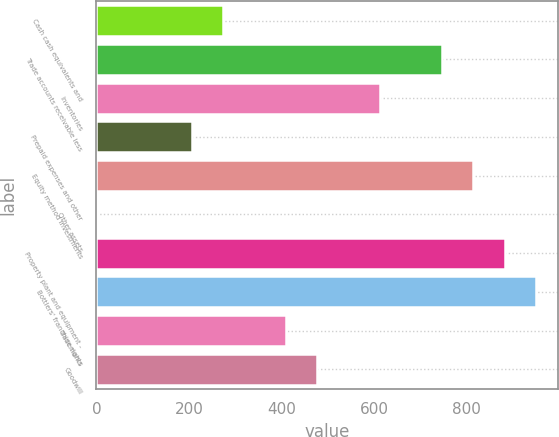<chart> <loc_0><loc_0><loc_500><loc_500><bar_chart><fcel>Cash cash equivalents and<fcel>Trade accounts receivable less<fcel>Inventories<fcel>Prepaid expenses and other<fcel>Equity method investments<fcel>Other assets<fcel>Property plant and equipment -<fcel>Bottlers' franchise rights<fcel>Trademarks<fcel>Goodwill<nl><fcel>273.4<fcel>746.6<fcel>611.4<fcel>205.8<fcel>814.2<fcel>3<fcel>881.8<fcel>949.4<fcel>408.6<fcel>476.2<nl></chart> 